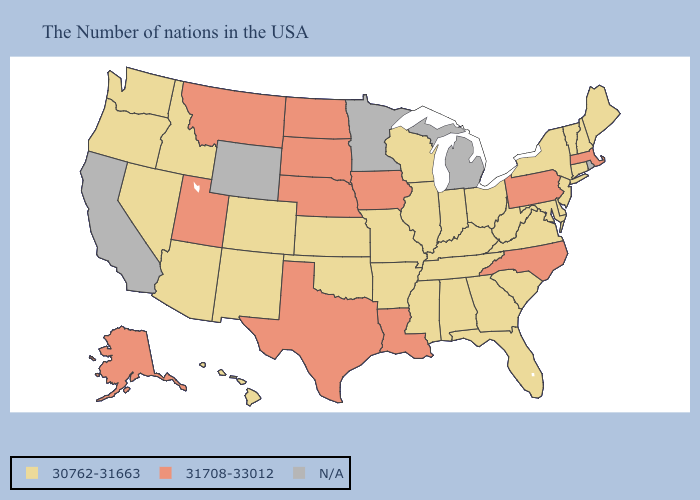Name the states that have a value in the range N/A?
Give a very brief answer. Rhode Island, Michigan, Minnesota, Wyoming, California. Name the states that have a value in the range N/A?
Concise answer only. Rhode Island, Michigan, Minnesota, Wyoming, California. What is the highest value in the West ?
Quick response, please. 31708-33012. Which states hav the highest value in the South?
Concise answer only. North Carolina, Louisiana, Texas. Does North Carolina have the highest value in the USA?
Concise answer only. Yes. Name the states that have a value in the range 31708-33012?
Give a very brief answer. Massachusetts, Pennsylvania, North Carolina, Louisiana, Iowa, Nebraska, Texas, South Dakota, North Dakota, Utah, Montana, Alaska. Is the legend a continuous bar?
Quick response, please. No. What is the highest value in states that border Idaho?
Keep it brief. 31708-33012. What is the value of Virginia?
Write a very short answer. 30762-31663. Name the states that have a value in the range 30762-31663?
Be succinct. Maine, New Hampshire, Vermont, Connecticut, New York, New Jersey, Delaware, Maryland, Virginia, South Carolina, West Virginia, Ohio, Florida, Georgia, Kentucky, Indiana, Alabama, Tennessee, Wisconsin, Illinois, Mississippi, Missouri, Arkansas, Kansas, Oklahoma, Colorado, New Mexico, Arizona, Idaho, Nevada, Washington, Oregon, Hawaii. What is the highest value in states that border New York?
Short answer required. 31708-33012. Name the states that have a value in the range 31708-33012?
Quick response, please. Massachusetts, Pennsylvania, North Carolina, Louisiana, Iowa, Nebraska, Texas, South Dakota, North Dakota, Utah, Montana, Alaska. Name the states that have a value in the range 31708-33012?
Be succinct. Massachusetts, Pennsylvania, North Carolina, Louisiana, Iowa, Nebraska, Texas, South Dakota, North Dakota, Utah, Montana, Alaska. 